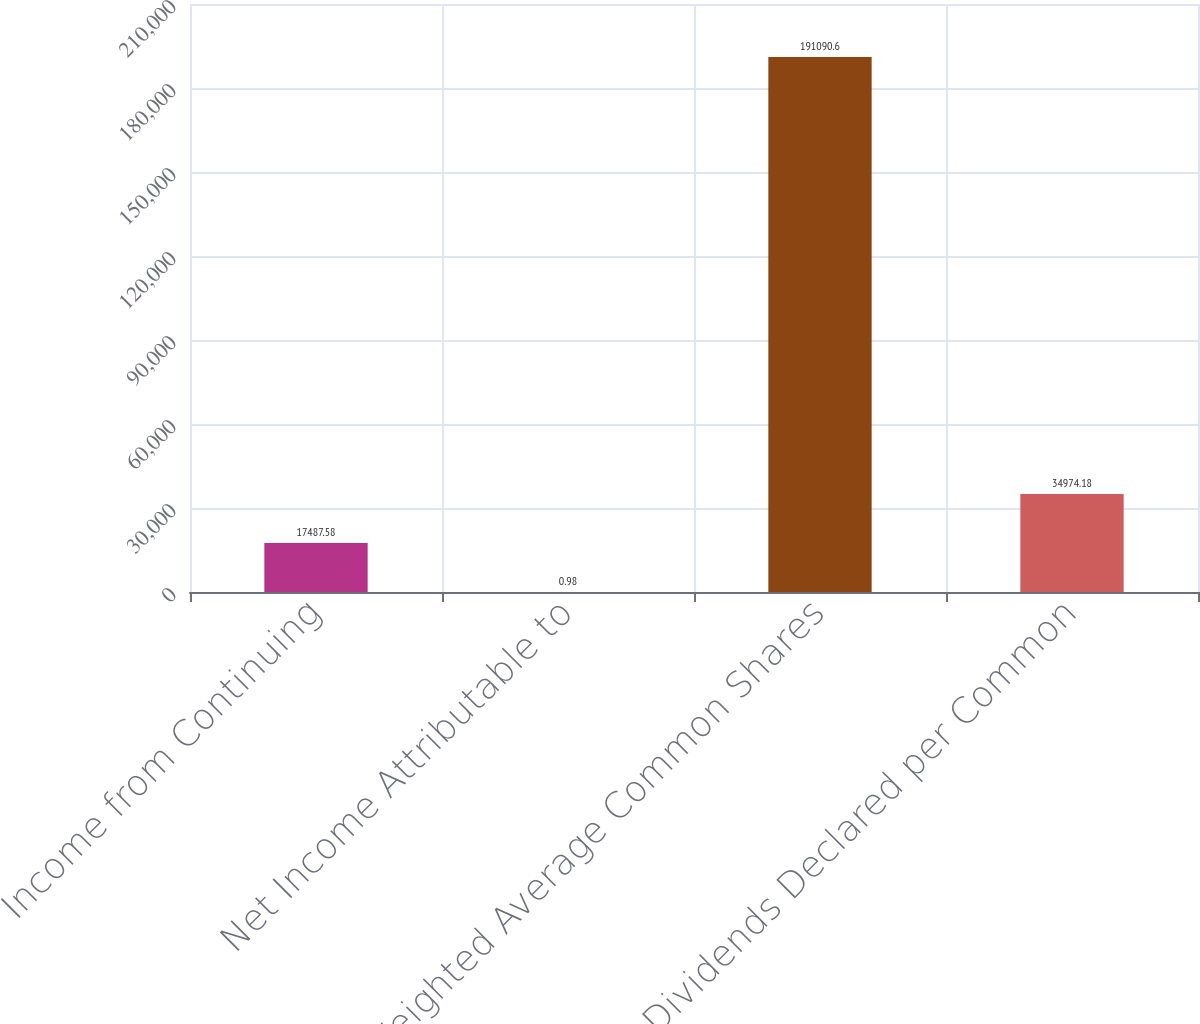Convert chart. <chart><loc_0><loc_0><loc_500><loc_500><bar_chart><fcel>Income from Continuing<fcel>Net Income Attributable to<fcel>Weighted Average Common Shares<fcel>Dividends Declared per Common<nl><fcel>17487.6<fcel>0.98<fcel>191091<fcel>34974.2<nl></chart> 